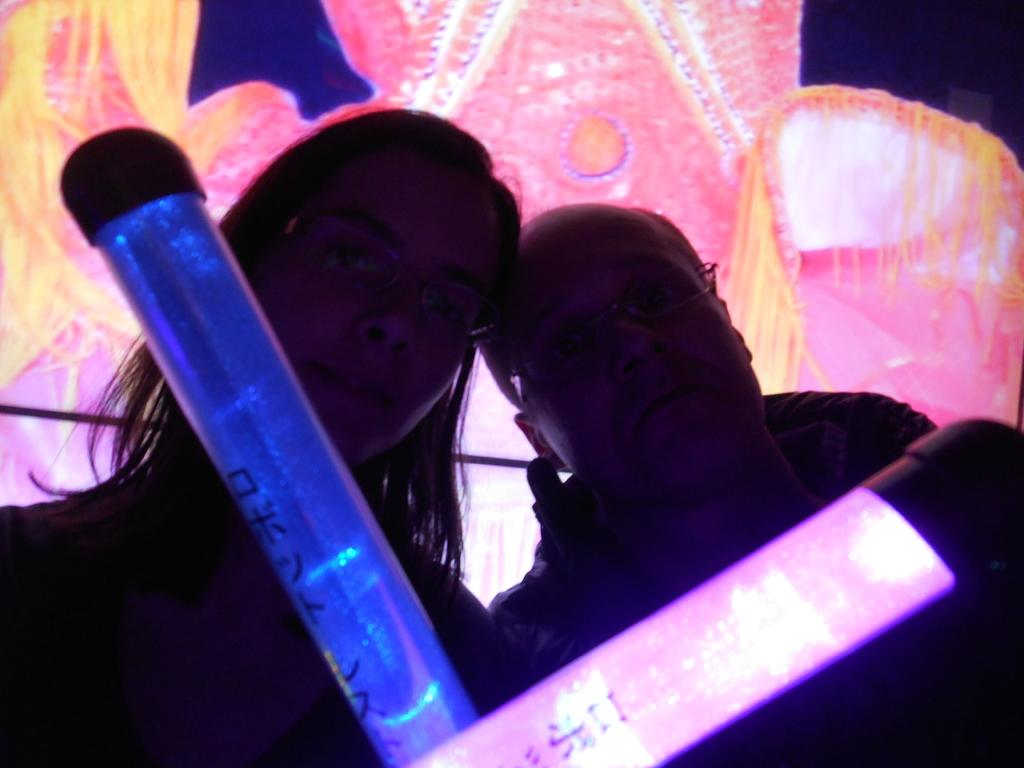How many people are in the image? There are persons standing in the image. What are the persons holding in their hands? The persons are holding light sticks. Can you describe the decoration visible in the image? There is decoration with cloth visible at the back. Are there any rabbits playing drums on the road in the image? No, there are no rabbits or drums on the road in the image. 